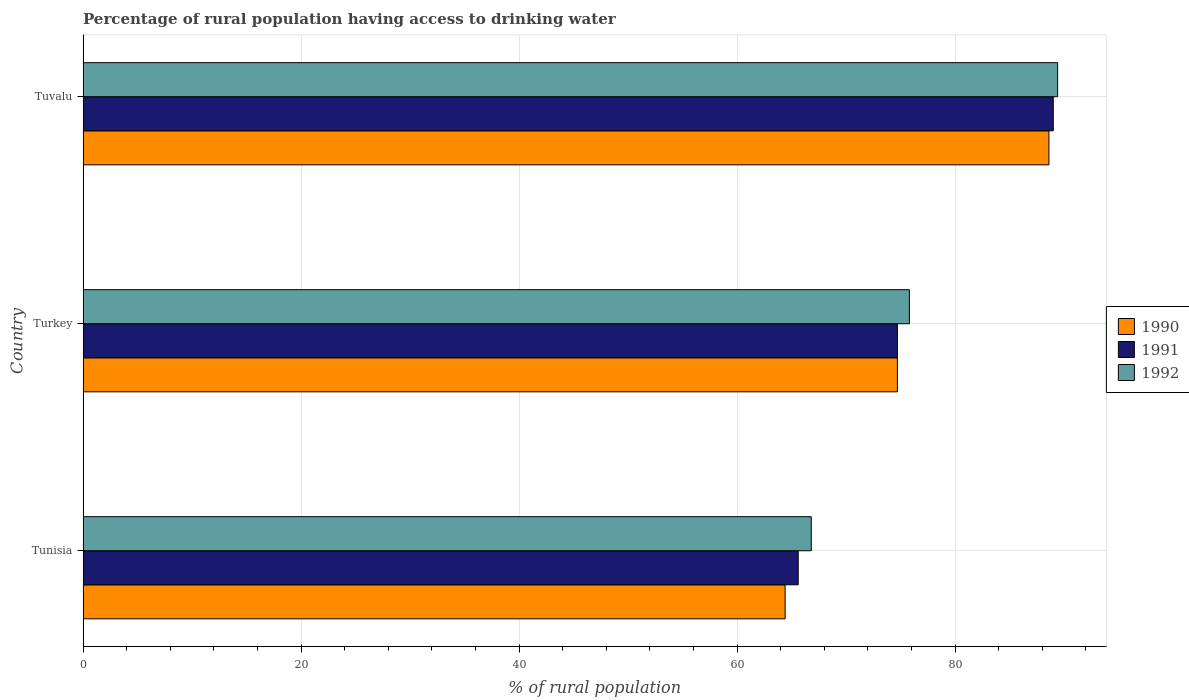Are the number of bars per tick equal to the number of legend labels?
Offer a terse response. Yes. Are the number of bars on each tick of the Y-axis equal?
Your response must be concise. Yes. How many bars are there on the 1st tick from the top?
Provide a short and direct response. 3. How many bars are there on the 2nd tick from the bottom?
Keep it short and to the point. 3. What is the percentage of rural population having access to drinking water in 1990 in Turkey?
Keep it short and to the point. 74.7. Across all countries, what is the maximum percentage of rural population having access to drinking water in 1992?
Your response must be concise. 89.4. Across all countries, what is the minimum percentage of rural population having access to drinking water in 1990?
Ensure brevity in your answer.  64.4. In which country was the percentage of rural population having access to drinking water in 1991 maximum?
Your answer should be compact. Tuvalu. In which country was the percentage of rural population having access to drinking water in 1990 minimum?
Your response must be concise. Tunisia. What is the total percentage of rural population having access to drinking water in 1990 in the graph?
Provide a short and direct response. 227.7. What is the difference between the percentage of rural population having access to drinking water in 1992 in Tunisia and that in Tuvalu?
Your answer should be very brief. -22.6. What is the average percentage of rural population having access to drinking water in 1990 per country?
Provide a short and direct response. 75.9. What is the difference between the percentage of rural population having access to drinking water in 1992 and percentage of rural population having access to drinking water in 1990 in Tuvalu?
Offer a very short reply. 0.8. In how many countries, is the percentage of rural population having access to drinking water in 1992 greater than 36 %?
Your answer should be very brief. 3. What is the ratio of the percentage of rural population having access to drinking water in 1990 in Tunisia to that in Turkey?
Offer a very short reply. 0.86. Is the percentage of rural population having access to drinking water in 1990 in Tunisia less than that in Tuvalu?
Your answer should be very brief. Yes. Is the difference between the percentage of rural population having access to drinking water in 1992 in Tunisia and Turkey greater than the difference between the percentage of rural population having access to drinking water in 1990 in Tunisia and Turkey?
Keep it short and to the point. Yes. What is the difference between the highest and the second highest percentage of rural population having access to drinking water in 1992?
Give a very brief answer. 13.6. What is the difference between the highest and the lowest percentage of rural population having access to drinking water in 1992?
Your answer should be compact. 22.6. In how many countries, is the percentage of rural population having access to drinking water in 1991 greater than the average percentage of rural population having access to drinking water in 1991 taken over all countries?
Give a very brief answer. 1. How many bars are there?
Your response must be concise. 9. How many countries are there in the graph?
Offer a very short reply. 3. Are the values on the major ticks of X-axis written in scientific E-notation?
Keep it short and to the point. No. Does the graph contain any zero values?
Ensure brevity in your answer.  No. Does the graph contain grids?
Provide a short and direct response. Yes. How many legend labels are there?
Your response must be concise. 3. What is the title of the graph?
Make the answer very short. Percentage of rural population having access to drinking water. Does "1965" appear as one of the legend labels in the graph?
Provide a short and direct response. No. What is the label or title of the X-axis?
Make the answer very short. % of rural population. What is the label or title of the Y-axis?
Keep it short and to the point. Country. What is the % of rural population in 1990 in Tunisia?
Ensure brevity in your answer.  64.4. What is the % of rural population of 1991 in Tunisia?
Offer a very short reply. 65.6. What is the % of rural population in 1992 in Tunisia?
Ensure brevity in your answer.  66.8. What is the % of rural population of 1990 in Turkey?
Provide a succinct answer. 74.7. What is the % of rural population of 1991 in Turkey?
Provide a succinct answer. 74.7. What is the % of rural population of 1992 in Turkey?
Provide a succinct answer. 75.8. What is the % of rural population of 1990 in Tuvalu?
Offer a terse response. 88.6. What is the % of rural population in 1991 in Tuvalu?
Offer a very short reply. 89. What is the % of rural population in 1992 in Tuvalu?
Keep it short and to the point. 89.4. Across all countries, what is the maximum % of rural population in 1990?
Offer a very short reply. 88.6. Across all countries, what is the maximum % of rural population of 1991?
Provide a succinct answer. 89. Across all countries, what is the maximum % of rural population of 1992?
Keep it short and to the point. 89.4. Across all countries, what is the minimum % of rural population of 1990?
Provide a succinct answer. 64.4. Across all countries, what is the minimum % of rural population of 1991?
Your answer should be compact. 65.6. Across all countries, what is the minimum % of rural population in 1992?
Make the answer very short. 66.8. What is the total % of rural population of 1990 in the graph?
Ensure brevity in your answer.  227.7. What is the total % of rural population of 1991 in the graph?
Your answer should be very brief. 229.3. What is the total % of rural population of 1992 in the graph?
Ensure brevity in your answer.  232. What is the difference between the % of rural population of 1990 in Tunisia and that in Turkey?
Give a very brief answer. -10.3. What is the difference between the % of rural population in 1991 in Tunisia and that in Turkey?
Offer a terse response. -9.1. What is the difference between the % of rural population of 1990 in Tunisia and that in Tuvalu?
Your response must be concise. -24.2. What is the difference between the % of rural population in 1991 in Tunisia and that in Tuvalu?
Ensure brevity in your answer.  -23.4. What is the difference between the % of rural population of 1992 in Tunisia and that in Tuvalu?
Your answer should be compact. -22.6. What is the difference between the % of rural population in 1990 in Turkey and that in Tuvalu?
Provide a short and direct response. -13.9. What is the difference between the % of rural population of 1991 in Turkey and that in Tuvalu?
Make the answer very short. -14.3. What is the difference between the % of rural population of 1990 in Tunisia and the % of rural population of 1992 in Turkey?
Your answer should be very brief. -11.4. What is the difference between the % of rural population of 1991 in Tunisia and the % of rural population of 1992 in Turkey?
Your answer should be very brief. -10.2. What is the difference between the % of rural population in 1990 in Tunisia and the % of rural population in 1991 in Tuvalu?
Ensure brevity in your answer.  -24.6. What is the difference between the % of rural population of 1991 in Tunisia and the % of rural population of 1992 in Tuvalu?
Your answer should be very brief. -23.8. What is the difference between the % of rural population of 1990 in Turkey and the % of rural population of 1991 in Tuvalu?
Provide a short and direct response. -14.3. What is the difference between the % of rural population in 1990 in Turkey and the % of rural population in 1992 in Tuvalu?
Your response must be concise. -14.7. What is the difference between the % of rural population of 1991 in Turkey and the % of rural population of 1992 in Tuvalu?
Your answer should be compact. -14.7. What is the average % of rural population in 1990 per country?
Offer a very short reply. 75.9. What is the average % of rural population in 1991 per country?
Offer a very short reply. 76.43. What is the average % of rural population in 1992 per country?
Your answer should be compact. 77.33. What is the difference between the % of rural population of 1991 and % of rural population of 1992 in Tunisia?
Provide a succinct answer. -1.2. What is the difference between the % of rural population in 1990 and % of rural population in 1991 in Tuvalu?
Offer a very short reply. -0.4. What is the difference between the % of rural population in 1990 and % of rural population in 1992 in Tuvalu?
Keep it short and to the point. -0.8. What is the ratio of the % of rural population of 1990 in Tunisia to that in Turkey?
Give a very brief answer. 0.86. What is the ratio of the % of rural population in 1991 in Tunisia to that in Turkey?
Give a very brief answer. 0.88. What is the ratio of the % of rural population in 1992 in Tunisia to that in Turkey?
Your answer should be compact. 0.88. What is the ratio of the % of rural population of 1990 in Tunisia to that in Tuvalu?
Your answer should be compact. 0.73. What is the ratio of the % of rural population of 1991 in Tunisia to that in Tuvalu?
Keep it short and to the point. 0.74. What is the ratio of the % of rural population in 1992 in Tunisia to that in Tuvalu?
Your answer should be compact. 0.75. What is the ratio of the % of rural population in 1990 in Turkey to that in Tuvalu?
Your response must be concise. 0.84. What is the ratio of the % of rural population in 1991 in Turkey to that in Tuvalu?
Your answer should be compact. 0.84. What is the ratio of the % of rural population in 1992 in Turkey to that in Tuvalu?
Your response must be concise. 0.85. What is the difference between the highest and the second highest % of rural population in 1991?
Ensure brevity in your answer.  14.3. What is the difference between the highest and the lowest % of rural population in 1990?
Give a very brief answer. 24.2. What is the difference between the highest and the lowest % of rural population of 1991?
Offer a terse response. 23.4. What is the difference between the highest and the lowest % of rural population in 1992?
Provide a short and direct response. 22.6. 